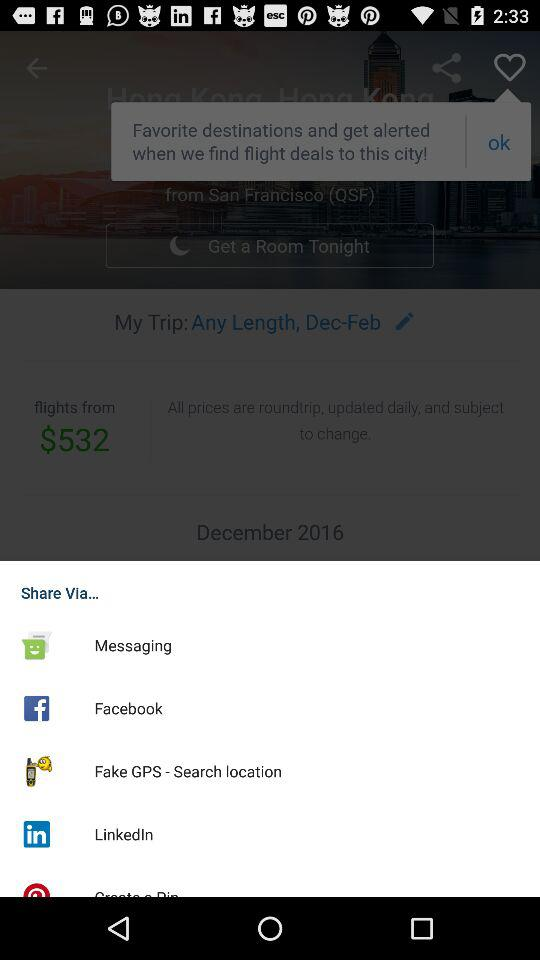Through what app can I share? The sharing options are "Messaging", "Facebook", "Fake GPS - Search location" and "LinkedIn". 